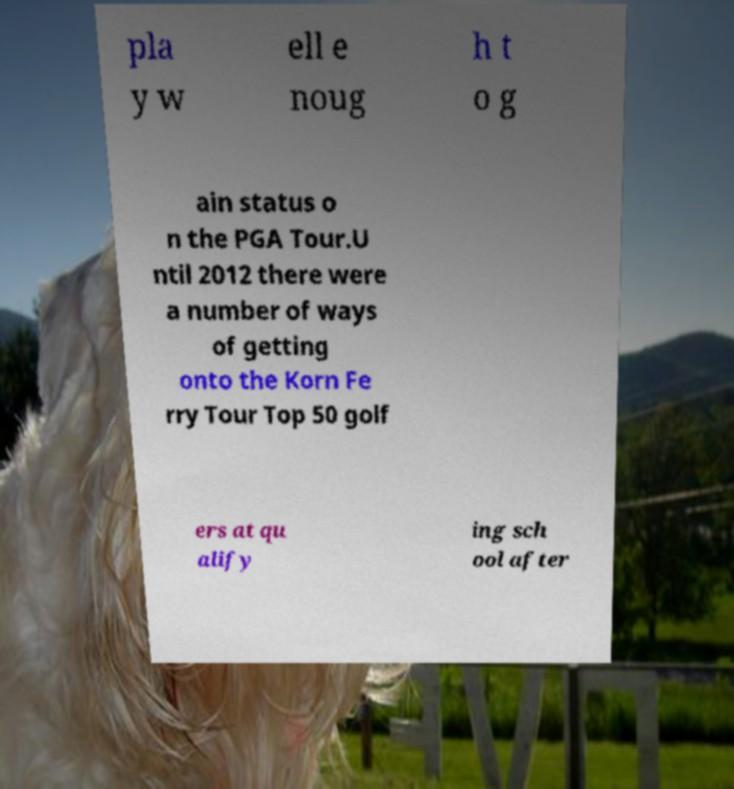Can you accurately transcribe the text from the provided image for me? pla y w ell e noug h t o g ain status o n the PGA Tour.U ntil 2012 there were a number of ways of getting onto the Korn Fe rry Tour Top 50 golf ers at qu alify ing sch ool after 